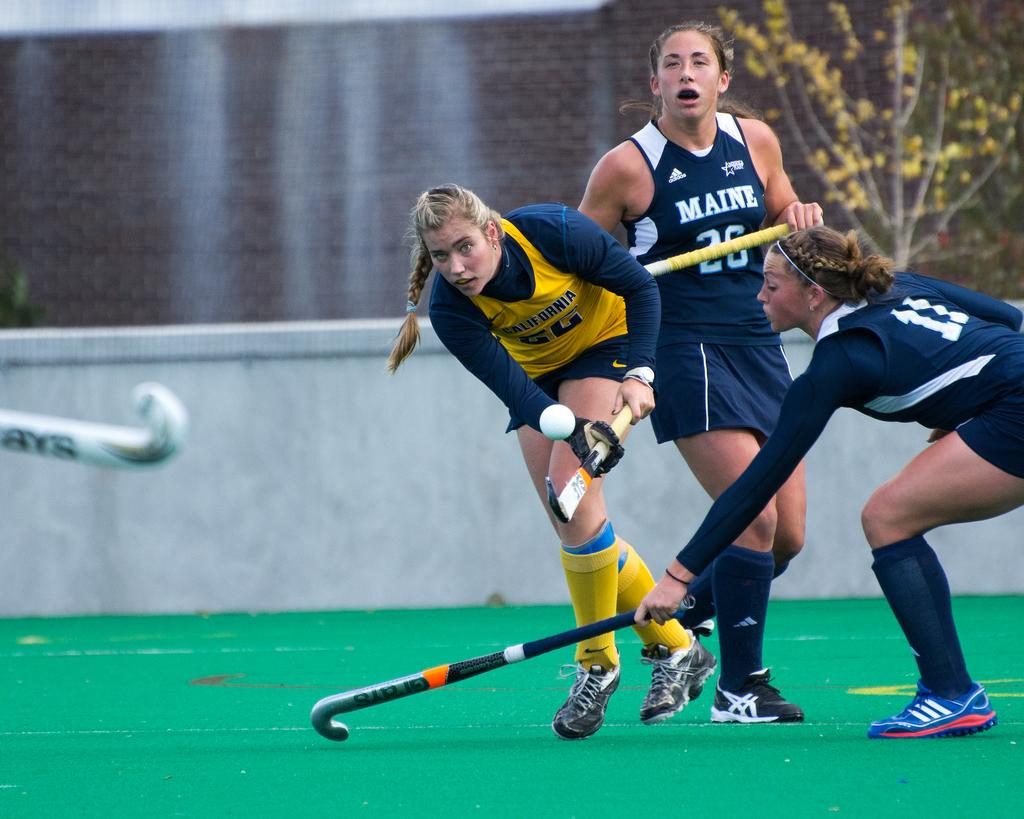<image>
Summarize the visual content of the image. Three female hockey players, two from Maine and one from California all holding sticks and going for a ball. 